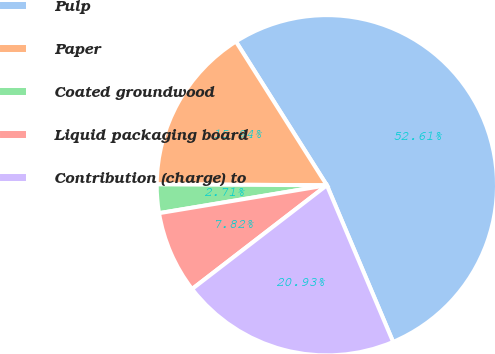Convert chart. <chart><loc_0><loc_0><loc_500><loc_500><pie_chart><fcel>Pulp<fcel>Paper<fcel>Coated groundwood<fcel>Liquid packaging board<fcel>Contribution (charge) to<nl><fcel>52.62%<fcel>15.94%<fcel>2.71%<fcel>7.82%<fcel>20.93%<nl></chart> 